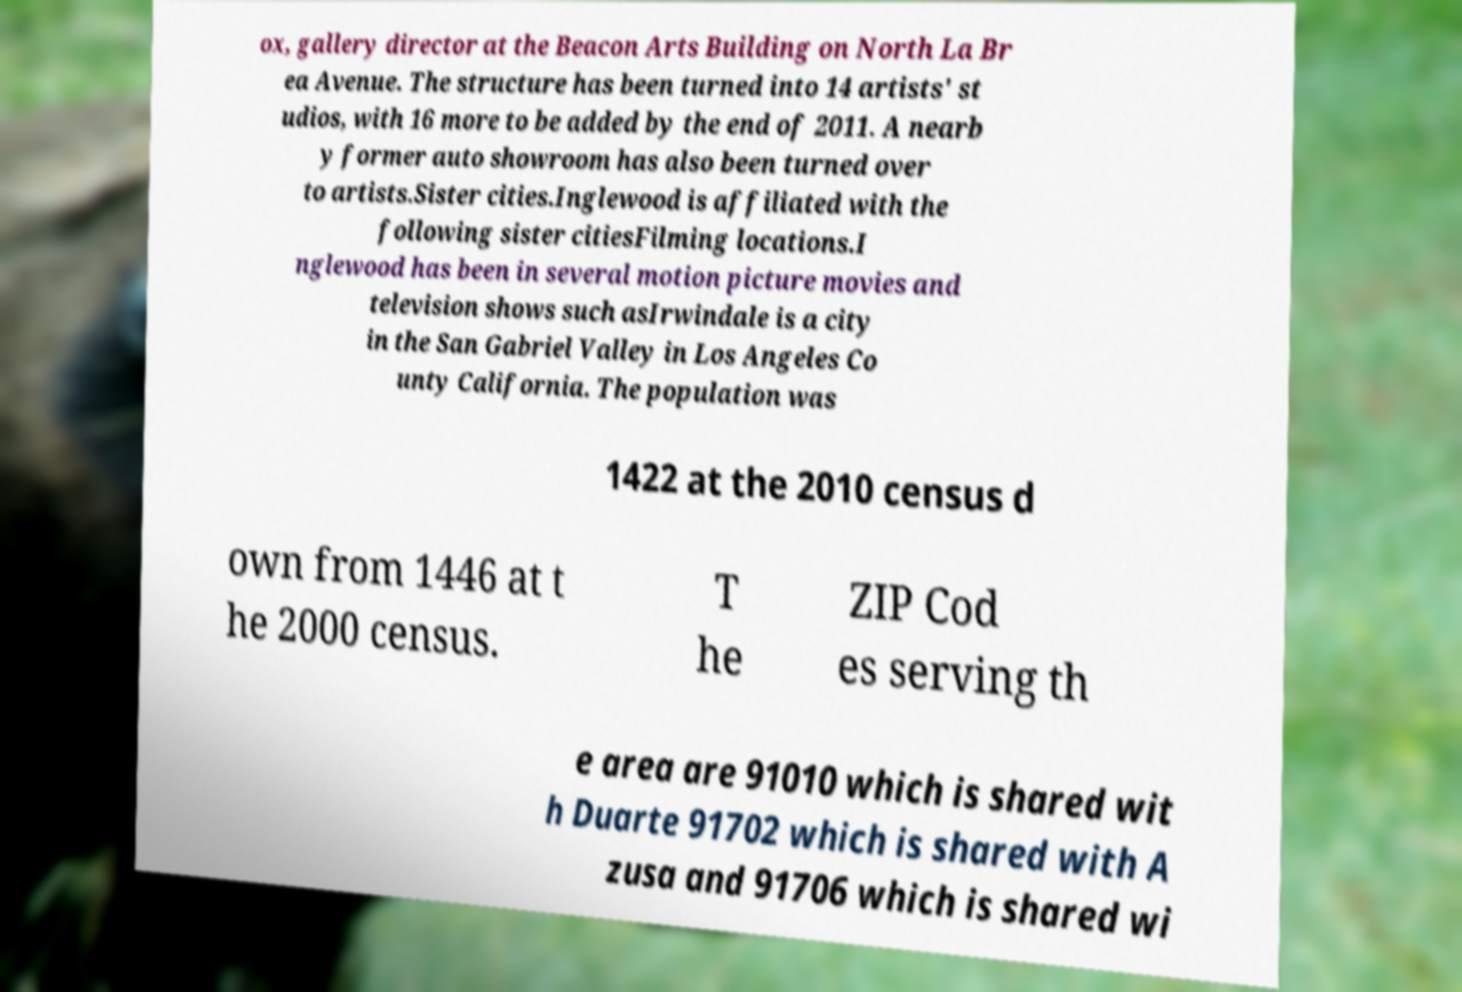There's text embedded in this image that I need extracted. Can you transcribe it verbatim? ox, gallery director at the Beacon Arts Building on North La Br ea Avenue. The structure has been turned into 14 artists' st udios, with 16 more to be added by the end of 2011. A nearb y former auto showroom has also been turned over to artists.Sister cities.Inglewood is affiliated with the following sister citiesFilming locations.I nglewood has been in several motion picture movies and television shows such asIrwindale is a city in the San Gabriel Valley in Los Angeles Co unty California. The population was 1422 at the 2010 census d own from 1446 at t he 2000 census. T he ZIP Cod es serving th e area are 91010 which is shared wit h Duarte 91702 which is shared with A zusa and 91706 which is shared wi 